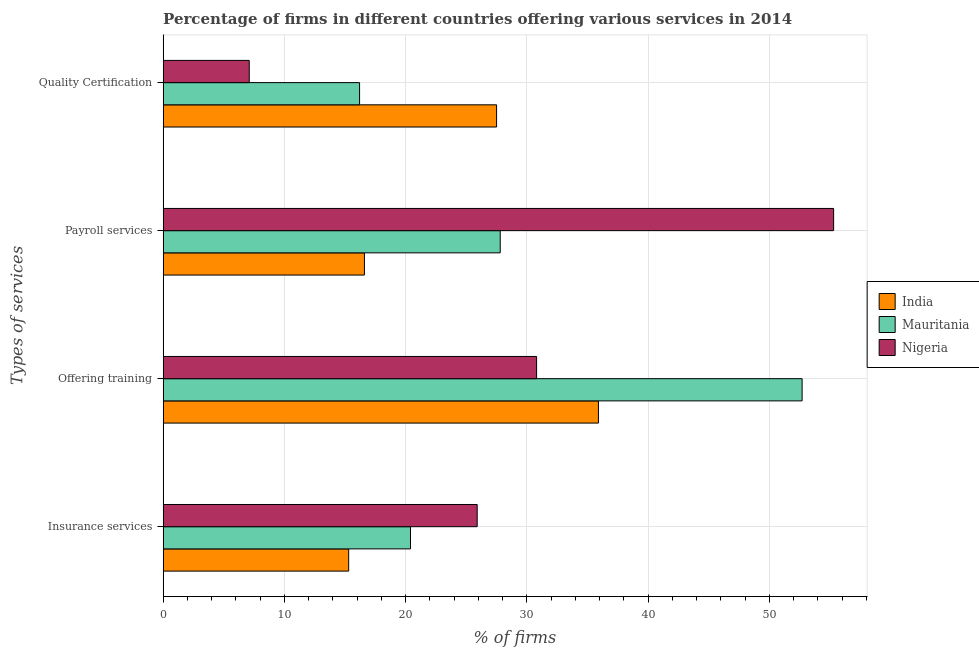How many groups of bars are there?
Offer a terse response. 4. How many bars are there on the 2nd tick from the top?
Ensure brevity in your answer.  3. What is the label of the 1st group of bars from the top?
Your answer should be very brief. Quality Certification. What is the percentage of firms offering training in Mauritania?
Provide a short and direct response. 52.7. Across all countries, what is the maximum percentage of firms offering insurance services?
Provide a succinct answer. 25.9. Across all countries, what is the minimum percentage of firms offering training?
Offer a very short reply. 30.8. In which country was the percentage of firms offering training maximum?
Your response must be concise. Mauritania. In which country was the percentage of firms offering training minimum?
Your answer should be compact. Nigeria. What is the total percentage of firms offering quality certification in the graph?
Give a very brief answer. 50.8. What is the difference between the percentage of firms offering payroll services in India and that in Mauritania?
Provide a short and direct response. -11.2. What is the difference between the percentage of firms offering quality certification in Mauritania and the percentage of firms offering training in Nigeria?
Your answer should be very brief. -14.6. What is the average percentage of firms offering quality certification per country?
Your answer should be very brief. 16.93. What is the difference between the percentage of firms offering training and percentage of firms offering payroll services in India?
Give a very brief answer. 19.3. In how many countries, is the percentage of firms offering training greater than 6 %?
Provide a succinct answer. 3. What is the ratio of the percentage of firms offering insurance services in Nigeria to that in India?
Your response must be concise. 1.69. Is the percentage of firms offering insurance services in India less than that in Mauritania?
Your answer should be compact. Yes. What is the difference between the highest and the second highest percentage of firms offering training?
Ensure brevity in your answer.  16.8. What is the difference between the highest and the lowest percentage of firms offering payroll services?
Your response must be concise. 38.7. In how many countries, is the percentage of firms offering insurance services greater than the average percentage of firms offering insurance services taken over all countries?
Provide a short and direct response. 1. Is the sum of the percentage of firms offering training in Nigeria and Mauritania greater than the maximum percentage of firms offering insurance services across all countries?
Offer a terse response. Yes. Is it the case that in every country, the sum of the percentage of firms offering quality certification and percentage of firms offering payroll services is greater than the sum of percentage of firms offering training and percentage of firms offering insurance services?
Your answer should be very brief. Yes. What does the 3rd bar from the top in Quality Certification represents?
Keep it short and to the point. India. What does the 2nd bar from the bottom in Quality Certification represents?
Provide a succinct answer. Mauritania. How many countries are there in the graph?
Offer a very short reply. 3. What is the difference between two consecutive major ticks on the X-axis?
Your answer should be very brief. 10. Does the graph contain any zero values?
Ensure brevity in your answer.  No. Does the graph contain grids?
Keep it short and to the point. Yes. What is the title of the graph?
Ensure brevity in your answer.  Percentage of firms in different countries offering various services in 2014. What is the label or title of the X-axis?
Your response must be concise. % of firms. What is the label or title of the Y-axis?
Provide a short and direct response. Types of services. What is the % of firms in Mauritania in Insurance services?
Offer a very short reply. 20.4. What is the % of firms in Nigeria in Insurance services?
Provide a short and direct response. 25.9. What is the % of firms of India in Offering training?
Offer a terse response. 35.9. What is the % of firms of Mauritania in Offering training?
Provide a succinct answer. 52.7. What is the % of firms of Nigeria in Offering training?
Give a very brief answer. 30.8. What is the % of firms of Mauritania in Payroll services?
Provide a short and direct response. 27.8. What is the % of firms of Nigeria in Payroll services?
Make the answer very short. 55.3. What is the % of firms in India in Quality Certification?
Give a very brief answer. 27.5. What is the % of firms in Nigeria in Quality Certification?
Keep it short and to the point. 7.1. Across all Types of services, what is the maximum % of firms of India?
Your response must be concise. 35.9. Across all Types of services, what is the maximum % of firms of Mauritania?
Keep it short and to the point. 52.7. Across all Types of services, what is the maximum % of firms of Nigeria?
Ensure brevity in your answer.  55.3. Across all Types of services, what is the minimum % of firms in India?
Ensure brevity in your answer.  15.3. What is the total % of firms of India in the graph?
Provide a succinct answer. 95.3. What is the total % of firms in Mauritania in the graph?
Ensure brevity in your answer.  117.1. What is the total % of firms in Nigeria in the graph?
Give a very brief answer. 119.1. What is the difference between the % of firms in India in Insurance services and that in Offering training?
Provide a succinct answer. -20.6. What is the difference between the % of firms of Mauritania in Insurance services and that in Offering training?
Keep it short and to the point. -32.3. What is the difference between the % of firms of India in Insurance services and that in Payroll services?
Offer a terse response. -1.3. What is the difference between the % of firms of Mauritania in Insurance services and that in Payroll services?
Your response must be concise. -7.4. What is the difference between the % of firms of Nigeria in Insurance services and that in Payroll services?
Give a very brief answer. -29.4. What is the difference between the % of firms of Mauritania in Insurance services and that in Quality Certification?
Offer a very short reply. 4.2. What is the difference between the % of firms of India in Offering training and that in Payroll services?
Your answer should be compact. 19.3. What is the difference between the % of firms of Mauritania in Offering training and that in Payroll services?
Keep it short and to the point. 24.9. What is the difference between the % of firms of Nigeria in Offering training and that in Payroll services?
Keep it short and to the point. -24.5. What is the difference between the % of firms of Mauritania in Offering training and that in Quality Certification?
Your answer should be compact. 36.5. What is the difference between the % of firms in Nigeria in Offering training and that in Quality Certification?
Keep it short and to the point. 23.7. What is the difference between the % of firms of Nigeria in Payroll services and that in Quality Certification?
Your answer should be very brief. 48.2. What is the difference between the % of firms of India in Insurance services and the % of firms of Mauritania in Offering training?
Provide a succinct answer. -37.4. What is the difference between the % of firms in India in Insurance services and the % of firms in Nigeria in Offering training?
Provide a succinct answer. -15.5. What is the difference between the % of firms of Mauritania in Insurance services and the % of firms of Nigeria in Payroll services?
Ensure brevity in your answer.  -34.9. What is the difference between the % of firms of India in Insurance services and the % of firms of Nigeria in Quality Certification?
Your answer should be very brief. 8.2. What is the difference between the % of firms in India in Offering training and the % of firms in Mauritania in Payroll services?
Your answer should be compact. 8.1. What is the difference between the % of firms of India in Offering training and the % of firms of Nigeria in Payroll services?
Keep it short and to the point. -19.4. What is the difference between the % of firms in India in Offering training and the % of firms in Nigeria in Quality Certification?
Offer a very short reply. 28.8. What is the difference between the % of firms in Mauritania in Offering training and the % of firms in Nigeria in Quality Certification?
Your answer should be compact. 45.6. What is the difference between the % of firms in Mauritania in Payroll services and the % of firms in Nigeria in Quality Certification?
Your answer should be very brief. 20.7. What is the average % of firms in India per Types of services?
Your answer should be very brief. 23.82. What is the average % of firms in Mauritania per Types of services?
Provide a succinct answer. 29.27. What is the average % of firms in Nigeria per Types of services?
Provide a short and direct response. 29.77. What is the difference between the % of firms of India and % of firms of Nigeria in Insurance services?
Give a very brief answer. -10.6. What is the difference between the % of firms in India and % of firms in Mauritania in Offering training?
Offer a terse response. -16.8. What is the difference between the % of firms of India and % of firms of Nigeria in Offering training?
Your response must be concise. 5.1. What is the difference between the % of firms of Mauritania and % of firms of Nigeria in Offering training?
Provide a succinct answer. 21.9. What is the difference between the % of firms of India and % of firms of Nigeria in Payroll services?
Your answer should be compact. -38.7. What is the difference between the % of firms in Mauritania and % of firms in Nigeria in Payroll services?
Offer a terse response. -27.5. What is the difference between the % of firms of India and % of firms of Nigeria in Quality Certification?
Provide a short and direct response. 20.4. What is the difference between the % of firms in Mauritania and % of firms in Nigeria in Quality Certification?
Give a very brief answer. 9.1. What is the ratio of the % of firms of India in Insurance services to that in Offering training?
Ensure brevity in your answer.  0.43. What is the ratio of the % of firms in Mauritania in Insurance services to that in Offering training?
Keep it short and to the point. 0.39. What is the ratio of the % of firms of Nigeria in Insurance services to that in Offering training?
Provide a succinct answer. 0.84. What is the ratio of the % of firms in India in Insurance services to that in Payroll services?
Your answer should be very brief. 0.92. What is the ratio of the % of firms in Mauritania in Insurance services to that in Payroll services?
Provide a succinct answer. 0.73. What is the ratio of the % of firms in Nigeria in Insurance services to that in Payroll services?
Your answer should be very brief. 0.47. What is the ratio of the % of firms in India in Insurance services to that in Quality Certification?
Keep it short and to the point. 0.56. What is the ratio of the % of firms in Mauritania in Insurance services to that in Quality Certification?
Keep it short and to the point. 1.26. What is the ratio of the % of firms of Nigeria in Insurance services to that in Quality Certification?
Ensure brevity in your answer.  3.65. What is the ratio of the % of firms in India in Offering training to that in Payroll services?
Your response must be concise. 2.16. What is the ratio of the % of firms of Mauritania in Offering training to that in Payroll services?
Offer a terse response. 1.9. What is the ratio of the % of firms in Nigeria in Offering training to that in Payroll services?
Make the answer very short. 0.56. What is the ratio of the % of firms of India in Offering training to that in Quality Certification?
Your answer should be very brief. 1.31. What is the ratio of the % of firms in Mauritania in Offering training to that in Quality Certification?
Offer a terse response. 3.25. What is the ratio of the % of firms in Nigeria in Offering training to that in Quality Certification?
Your response must be concise. 4.34. What is the ratio of the % of firms in India in Payroll services to that in Quality Certification?
Provide a short and direct response. 0.6. What is the ratio of the % of firms in Mauritania in Payroll services to that in Quality Certification?
Offer a very short reply. 1.72. What is the ratio of the % of firms of Nigeria in Payroll services to that in Quality Certification?
Keep it short and to the point. 7.79. What is the difference between the highest and the second highest % of firms in India?
Offer a terse response. 8.4. What is the difference between the highest and the second highest % of firms of Mauritania?
Your answer should be compact. 24.9. What is the difference between the highest and the second highest % of firms in Nigeria?
Provide a short and direct response. 24.5. What is the difference between the highest and the lowest % of firms of India?
Your response must be concise. 20.6. What is the difference between the highest and the lowest % of firms in Mauritania?
Ensure brevity in your answer.  36.5. What is the difference between the highest and the lowest % of firms of Nigeria?
Make the answer very short. 48.2. 